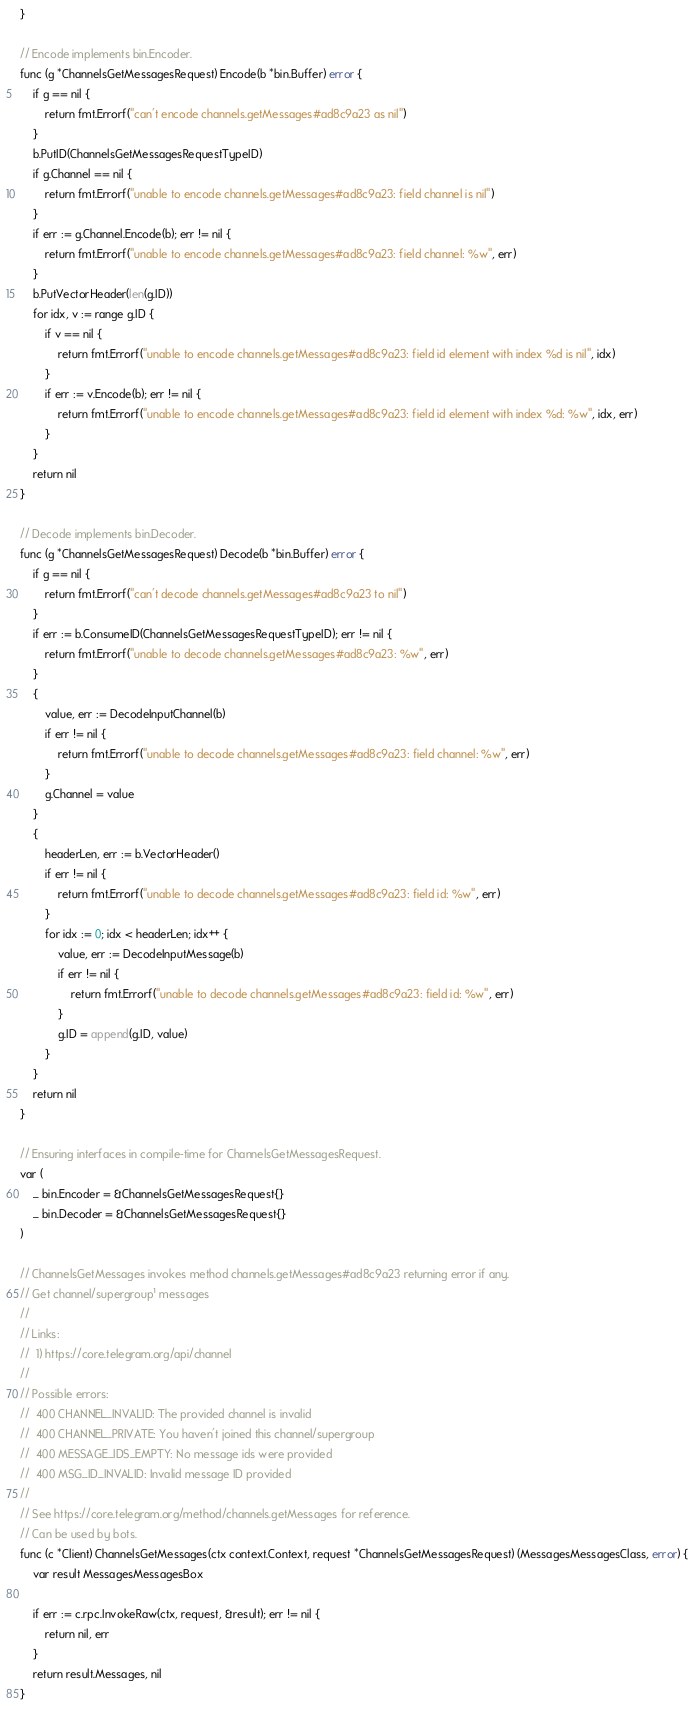Convert code to text. <code><loc_0><loc_0><loc_500><loc_500><_Go_>}

// Encode implements bin.Encoder.
func (g *ChannelsGetMessagesRequest) Encode(b *bin.Buffer) error {
	if g == nil {
		return fmt.Errorf("can't encode channels.getMessages#ad8c9a23 as nil")
	}
	b.PutID(ChannelsGetMessagesRequestTypeID)
	if g.Channel == nil {
		return fmt.Errorf("unable to encode channels.getMessages#ad8c9a23: field channel is nil")
	}
	if err := g.Channel.Encode(b); err != nil {
		return fmt.Errorf("unable to encode channels.getMessages#ad8c9a23: field channel: %w", err)
	}
	b.PutVectorHeader(len(g.ID))
	for idx, v := range g.ID {
		if v == nil {
			return fmt.Errorf("unable to encode channels.getMessages#ad8c9a23: field id element with index %d is nil", idx)
		}
		if err := v.Encode(b); err != nil {
			return fmt.Errorf("unable to encode channels.getMessages#ad8c9a23: field id element with index %d: %w", idx, err)
		}
	}
	return nil
}

// Decode implements bin.Decoder.
func (g *ChannelsGetMessagesRequest) Decode(b *bin.Buffer) error {
	if g == nil {
		return fmt.Errorf("can't decode channels.getMessages#ad8c9a23 to nil")
	}
	if err := b.ConsumeID(ChannelsGetMessagesRequestTypeID); err != nil {
		return fmt.Errorf("unable to decode channels.getMessages#ad8c9a23: %w", err)
	}
	{
		value, err := DecodeInputChannel(b)
		if err != nil {
			return fmt.Errorf("unable to decode channels.getMessages#ad8c9a23: field channel: %w", err)
		}
		g.Channel = value
	}
	{
		headerLen, err := b.VectorHeader()
		if err != nil {
			return fmt.Errorf("unable to decode channels.getMessages#ad8c9a23: field id: %w", err)
		}
		for idx := 0; idx < headerLen; idx++ {
			value, err := DecodeInputMessage(b)
			if err != nil {
				return fmt.Errorf("unable to decode channels.getMessages#ad8c9a23: field id: %w", err)
			}
			g.ID = append(g.ID, value)
		}
	}
	return nil
}

// Ensuring interfaces in compile-time for ChannelsGetMessagesRequest.
var (
	_ bin.Encoder = &ChannelsGetMessagesRequest{}
	_ bin.Decoder = &ChannelsGetMessagesRequest{}
)

// ChannelsGetMessages invokes method channels.getMessages#ad8c9a23 returning error if any.
// Get channel/supergroup¹ messages
//
// Links:
//  1) https://core.telegram.org/api/channel
//
// Possible errors:
//  400 CHANNEL_INVALID: The provided channel is invalid
//  400 CHANNEL_PRIVATE: You haven't joined this channel/supergroup
//  400 MESSAGE_IDS_EMPTY: No message ids were provided
//  400 MSG_ID_INVALID: Invalid message ID provided
//
// See https://core.telegram.org/method/channels.getMessages for reference.
// Can be used by bots.
func (c *Client) ChannelsGetMessages(ctx context.Context, request *ChannelsGetMessagesRequest) (MessagesMessagesClass, error) {
	var result MessagesMessagesBox

	if err := c.rpc.InvokeRaw(ctx, request, &result); err != nil {
		return nil, err
	}
	return result.Messages, nil
}
</code> 